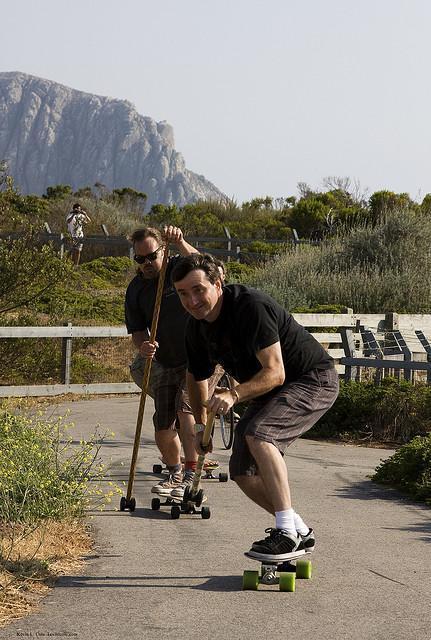How many are there on the skateboard?
Give a very brief answer. 3. How many people are wearing sunglasses?
Give a very brief answer. 1. How many people are there?
Give a very brief answer. 2. How many elephants are visible?
Give a very brief answer. 0. 